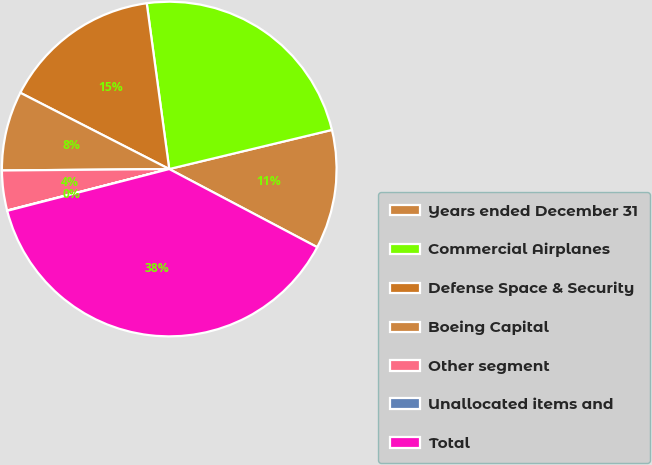<chart> <loc_0><loc_0><loc_500><loc_500><pie_chart><fcel>Years ended December 31<fcel>Commercial Airplanes<fcel>Defense Space & Security<fcel>Boeing Capital<fcel>Other segment<fcel>Unallocated items and<fcel>Total<nl><fcel>11.49%<fcel>23.39%<fcel>15.32%<fcel>7.67%<fcel>3.85%<fcel>0.03%<fcel>38.25%<nl></chart> 